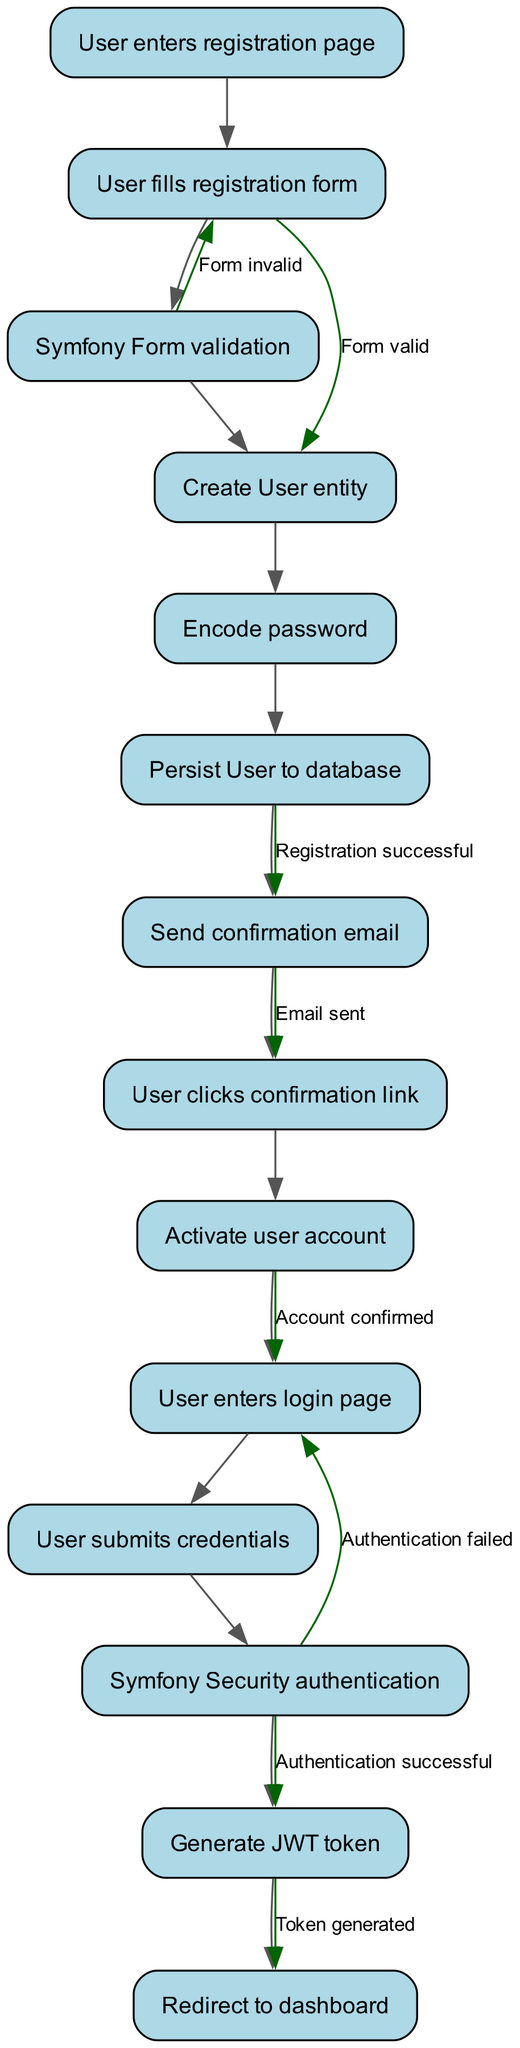What are the total number of nodes in this diagram? The diagram lists all the steps involved in the user registration and authentication process. By counting each unique step (node), we arrive at the total number: User enters registration page, User fills registration form, Symfony Form validation, Create User entity, Encode password, Persist User to database, Send confirmation email, User clicks confirmation link, Activate user account, User enters login page, User submits credentials, Symfony Security authentication, Generate JWT token, Redirect to dashboard, which totals to 13 nodes.
Answer: 13 What happens if the form is invalid? Upon validation of the form, if it is deemed invalid, the flow will redirect the user back to the "User fills registration form" node. This is indicated by the edge labeled "Form invalid".
Answer: User fills registration form What node follows the "Send confirmation email" node? After the "Send confirmation email" node, the next action the user takes is to click on the confirmation link, which is represented by the "User clicks confirmation link" node.
Answer: User clicks confirmation link How many edges are there in total? To compute the total number of edges, we consider the connections made between the nodes, as well as the distinct labels given to specific transitions between the process steps. By counting them, we can see there are a total of 8 edges, connecting the 13 nodes.
Answer: 8 What is the outcome after successful authentication? Once authentication is successful, the flow leads to the generation of a JWT token as indicated by the edge labeled "Authentication successful", before redirecting to the dashboard. The subsequent node after successful authentication is "Generate JWT token".
Answer: Generate JWT token What happens next after the user account is activated? After the activation of the user account, the following action is for the user to enter the login page, which is represented by the "User enters login page" node. This is a sequential step that comes directly after the account confirmation.
Answer: User enters login page What is the initial action taken in the diagram? The process begins with the user accessing the registration page. This first node is named "User enters registration page", which initiates the entire user registration and authentication process.
Answer: User enters registration page Which node indicates a successful registration? The successful registration is indicated by the node "Send confirmation email", which follows the edge labeled "Registration successful" after persisting the user to the database.
Answer: Send confirmation email 